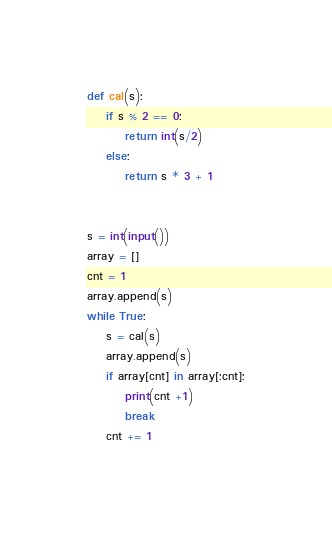<code> <loc_0><loc_0><loc_500><loc_500><_Python_>def cal(s):
    if s % 2 == 0:
        return int(s/2)
    else:
        return s * 3 + 1


s = int(input())
array = []
cnt = 1
array.append(s)
while True:
    s = cal(s)
    array.append(s)
    if array[cnt] in array[:cnt]:
        print(cnt +1)
        break
    cnt += 1
</code> 